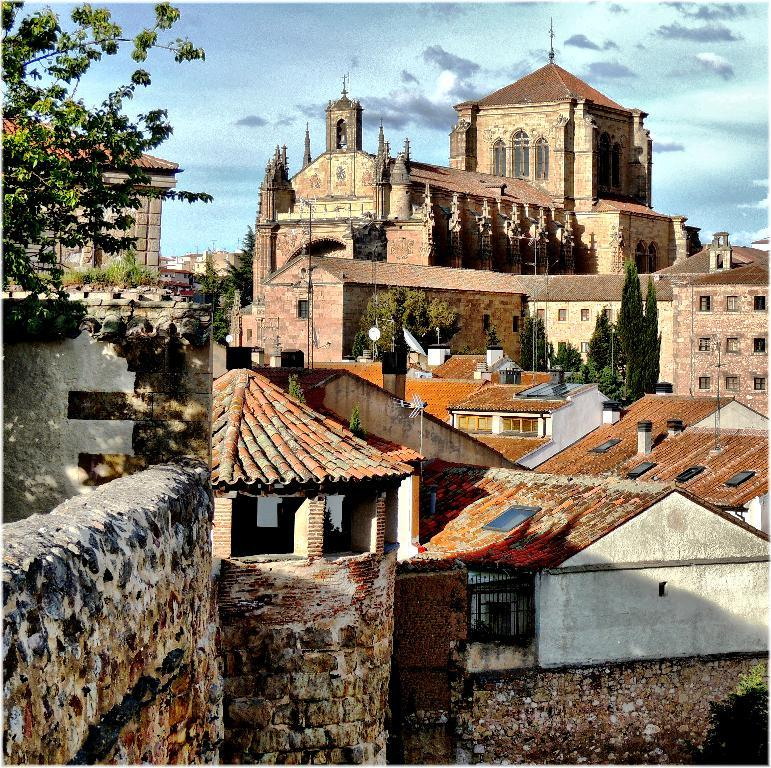What type of structures are visible in the image? There are many buildings in the image. What colors are the buildings? The buildings are in brown and cream colors. What type of vegetation is present in the image? There are plants in green color on the left side of the image. What is the color of the sky in the image? The sky is in blue and gray colors at the back of the image. What type of crate is used for the treatment of the plants in the image? There is no crate or treatment of plants mentioned in the image; it only shows buildings, plants, and the sky. 